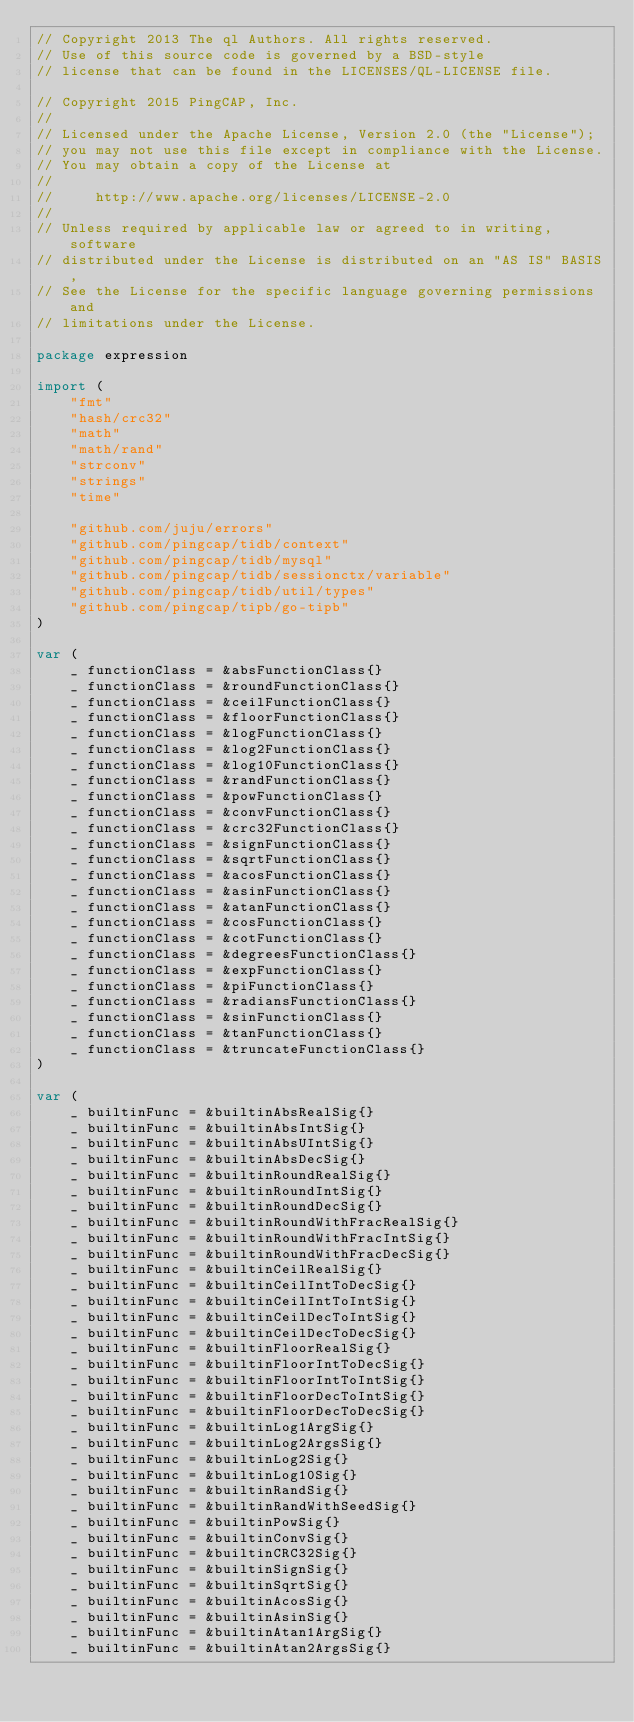<code> <loc_0><loc_0><loc_500><loc_500><_Go_>// Copyright 2013 The ql Authors. All rights reserved.
// Use of this source code is governed by a BSD-style
// license that can be found in the LICENSES/QL-LICENSE file.

// Copyright 2015 PingCAP, Inc.
//
// Licensed under the Apache License, Version 2.0 (the "License");
// you may not use this file except in compliance with the License.
// You may obtain a copy of the License at
//
//     http://www.apache.org/licenses/LICENSE-2.0
//
// Unless required by applicable law or agreed to in writing, software
// distributed under the License is distributed on an "AS IS" BASIS,
// See the License for the specific language governing permissions and
// limitations under the License.

package expression

import (
	"fmt"
	"hash/crc32"
	"math"
	"math/rand"
	"strconv"
	"strings"
	"time"

	"github.com/juju/errors"
	"github.com/pingcap/tidb/context"
	"github.com/pingcap/tidb/mysql"
	"github.com/pingcap/tidb/sessionctx/variable"
	"github.com/pingcap/tidb/util/types"
	"github.com/pingcap/tipb/go-tipb"
)

var (
	_ functionClass = &absFunctionClass{}
	_ functionClass = &roundFunctionClass{}
	_ functionClass = &ceilFunctionClass{}
	_ functionClass = &floorFunctionClass{}
	_ functionClass = &logFunctionClass{}
	_ functionClass = &log2FunctionClass{}
	_ functionClass = &log10FunctionClass{}
	_ functionClass = &randFunctionClass{}
	_ functionClass = &powFunctionClass{}
	_ functionClass = &convFunctionClass{}
	_ functionClass = &crc32FunctionClass{}
	_ functionClass = &signFunctionClass{}
	_ functionClass = &sqrtFunctionClass{}
	_ functionClass = &acosFunctionClass{}
	_ functionClass = &asinFunctionClass{}
	_ functionClass = &atanFunctionClass{}
	_ functionClass = &cosFunctionClass{}
	_ functionClass = &cotFunctionClass{}
	_ functionClass = &degreesFunctionClass{}
	_ functionClass = &expFunctionClass{}
	_ functionClass = &piFunctionClass{}
	_ functionClass = &radiansFunctionClass{}
	_ functionClass = &sinFunctionClass{}
	_ functionClass = &tanFunctionClass{}
	_ functionClass = &truncateFunctionClass{}
)

var (
	_ builtinFunc = &builtinAbsRealSig{}
	_ builtinFunc = &builtinAbsIntSig{}
	_ builtinFunc = &builtinAbsUIntSig{}
	_ builtinFunc = &builtinAbsDecSig{}
	_ builtinFunc = &builtinRoundRealSig{}
	_ builtinFunc = &builtinRoundIntSig{}
	_ builtinFunc = &builtinRoundDecSig{}
	_ builtinFunc = &builtinRoundWithFracRealSig{}
	_ builtinFunc = &builtinRoundWithFracIntSig{}
	_ builtinFunc = &builtinRoundWithFracDecSig{}
	_ builtinFunc = &builtinCeilRealSig{}
	_ builtinFunc = &builtinCeilIntToDecSig{}
	_ builtinFunc = &builtinCeilIntToIntSig{}
	_ builtinFunc = &builtinCeilDecToIntSig{}
	_ builtinFunc = &builtinCeilDecToDecSig{}
	_ builtinFunc = &builtinFloorRealSig{}
	_ builtinFunc = &builtinFloorIntToDecSig{}
	_ builtinFunc = &builtinFloorIntToIntSig{}
	_ builtinFunc = &builtinFloorDecToIntSig{}
	_ builtinFunc = &builtinFloorDecToDecSig{}
	_ builtinFunc = &builtinLog1ArgSig{}
	_ builtinFunc = &builtinLog2ArgsSig{}
	_ builtinFunc = &builtinLog2Sig{}
	_ builtinFunc = &builtinLog10Sig{}
	_ builtinFunc = &builtinRandSig{}
	_ builtinFunc = &builtinRandWithSeedSig{}
	_ builtinFunc = &builtinPowSig{}
	_ builtinFunc = &builtinConvSig{}
	_ builtinFunc = &builtinCRC32Sig{}
	_ builtinFunc = &builtinSignSig{}
	_ builtinFunc = &builtinSqrtSig{}
	_ builtinFunc = &builtinAcosSig{}
	_ builtinFunc = &builtinAsinSig{}
	_ builtinFunc = &builtinAtan1ArgSig{}
	_ builtinFunc = &builtinAtan2ArgsSig{}</code> 